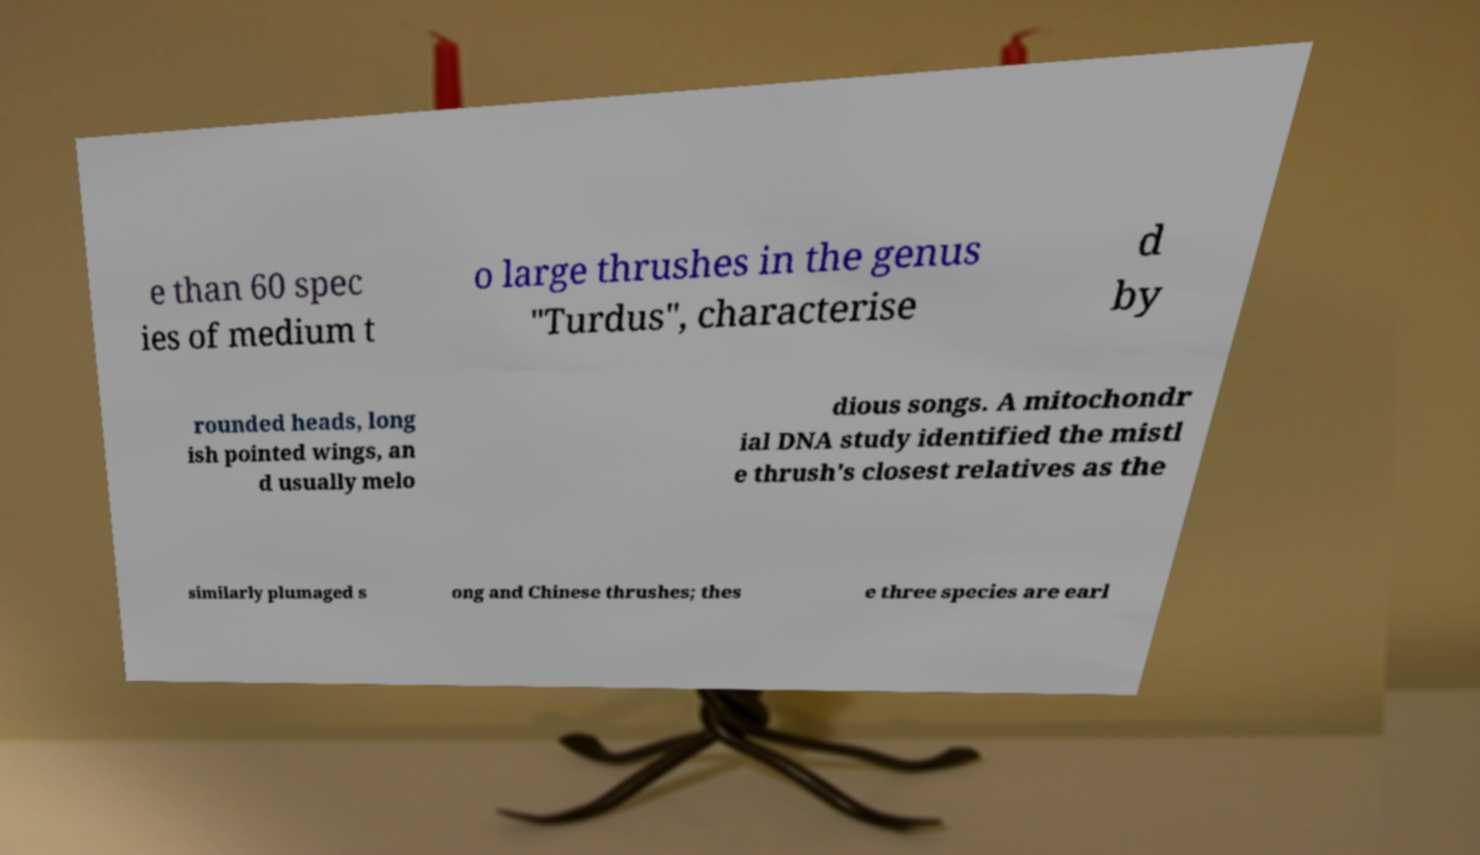There's text embedded in this image that I need extracted. Can you transcribe it verbatim? e than 60 spec ies of medium t o large thrushes in the genus "Turdus", characterise d by rounded heads, long ish pointed wings, an d usually melo dious songs. A mitochondr ial DNA study identified the mistl e thrush's closest relatives as the similarly plumaged s ong and Chinese thrushes; thes e three species are earl 